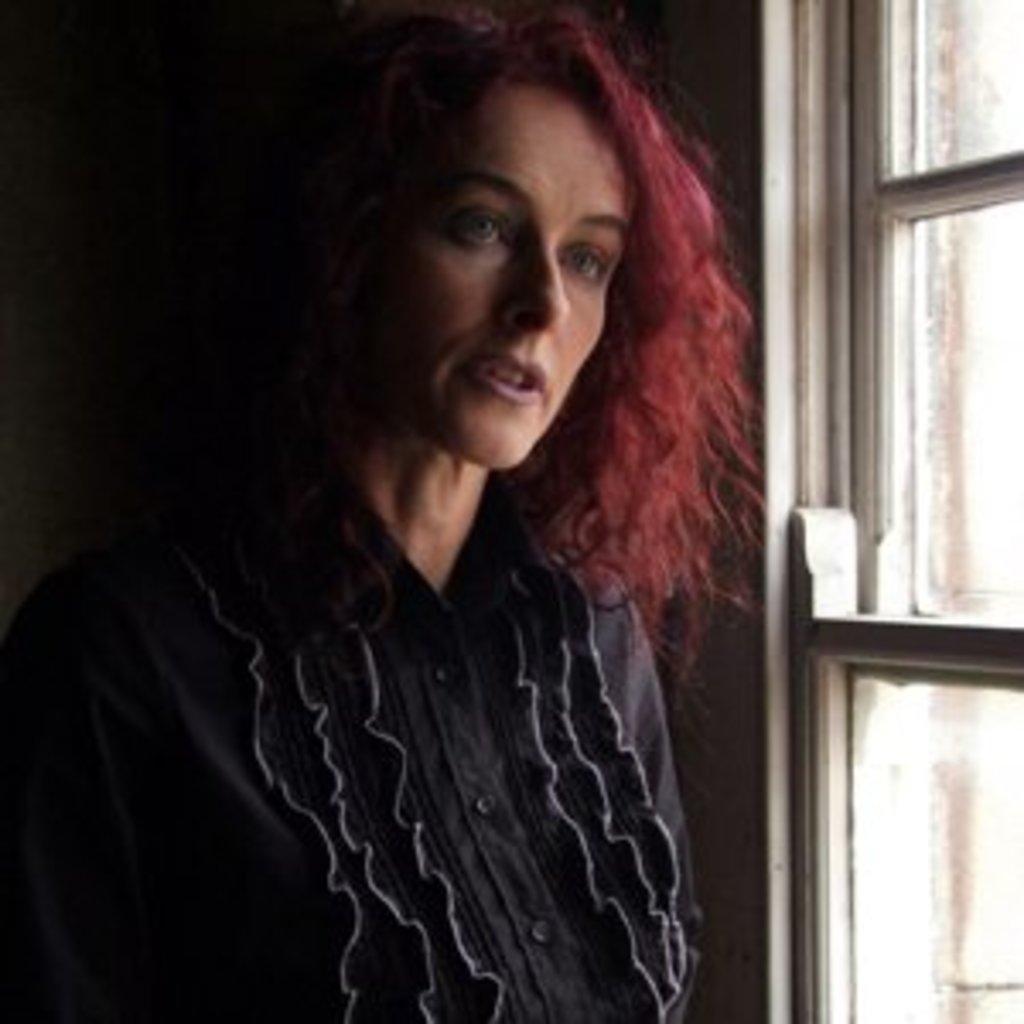Please provide a concise description of this image. In this image there is a lady standing beside the glass window. 